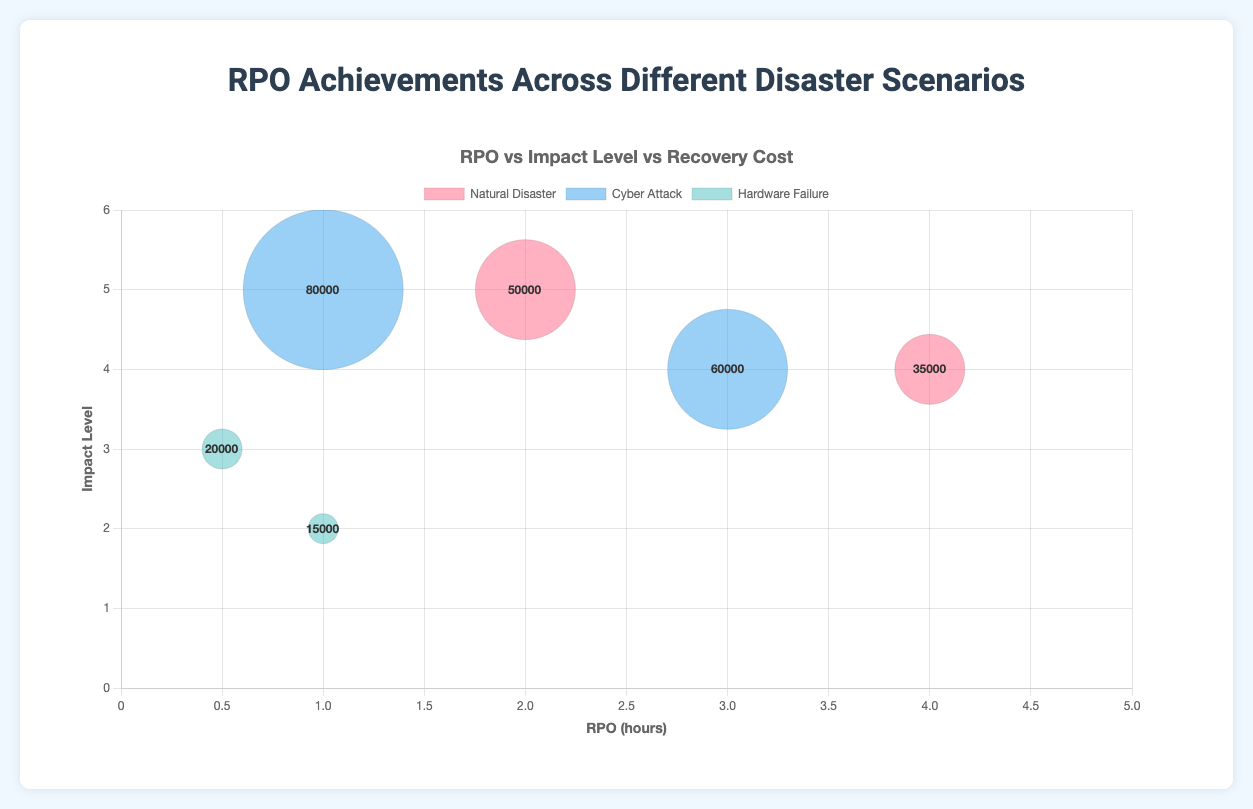What is the title of the chart? The title of the chart is often displayed at the top and provides a summary of what the chart is about. Here, the title is "RPO vs Impact Level vs Recovery Cost" based on the provided code.
Answer: RPO vs Impact Level vs Recovery Cost Which disaster scenario has the overall highest recovery cost? To determine which disaster scenario has the highest recovery cost, look at the bubble sizes and their labels in the tooltip. The Cyber Attack scenario has the largest bubble at $80,000 recovery cost.
Answer: Cyber Attack What is the RPO for the Tokyo Datacenter under Hardware Failure? Locate the data point for the Tokyo Datacenter, which falls under the Hardware Failure dataset. According to the data, its RPO is 0.5 hours.
Answer: 0.5 hours How many data points are there in total? Count each individual bubble across all datasets. The chart has two bubbles for each disaster type: Natural Disaster (2), Cyber Attack (2), and Hardware Failure (2), totaling 6 data points.
Answer: 6 Compare the impact levels of San Francisco and Seattle Datacenters under Natural Disasters. Which one is higher? Identify the impact levels for both datacenters under the Natural Disaster dataset. San Francisco has an impact level of 5, while Seattle has an impact level of 4. 5 is higher than 4.
Answer: San Francisco What is the combined recovery cost for all Cyber Attack scenarios? Sum up the recovery costs for both Cyber Attack scenarios: $80,000 (New York) and $60,000 (London). The total is $80,000 + $60,000 = $140,000.
Answer: $140,000 Which data point has the lowest impact level, and what is its RPO? Look for the data point with the smallest y-axis value. The Mumbai Datacenter under Hardware Failure has the lowest impact level of 2, and its RPO is 1 hour.
Answer: Mumbai Datacenter with 1 hour What is the average RPO for all Natural Disaster scenarios? Sum the RPO values for San Francisco (2 hours) and Seattle (4 hours) and divide by the number of data points (2). (2 + 4) / 2 = 3 hours.
Answer: 3 hours Between Cyber Attacks and Hardware Failures, which has a higher average impact level? Calculate the average impact level for each: Cyber Attack (New York: 5, London: 4, average (5+4)/2 = 4.5); Hardware Failure (Tokyo: 3, Mumbai: 2, average (3+2)/2 = 2.5). Cyber Attacks have a higher average impact level (4.5 vs 2.5).
Answer: Cyber Attack 